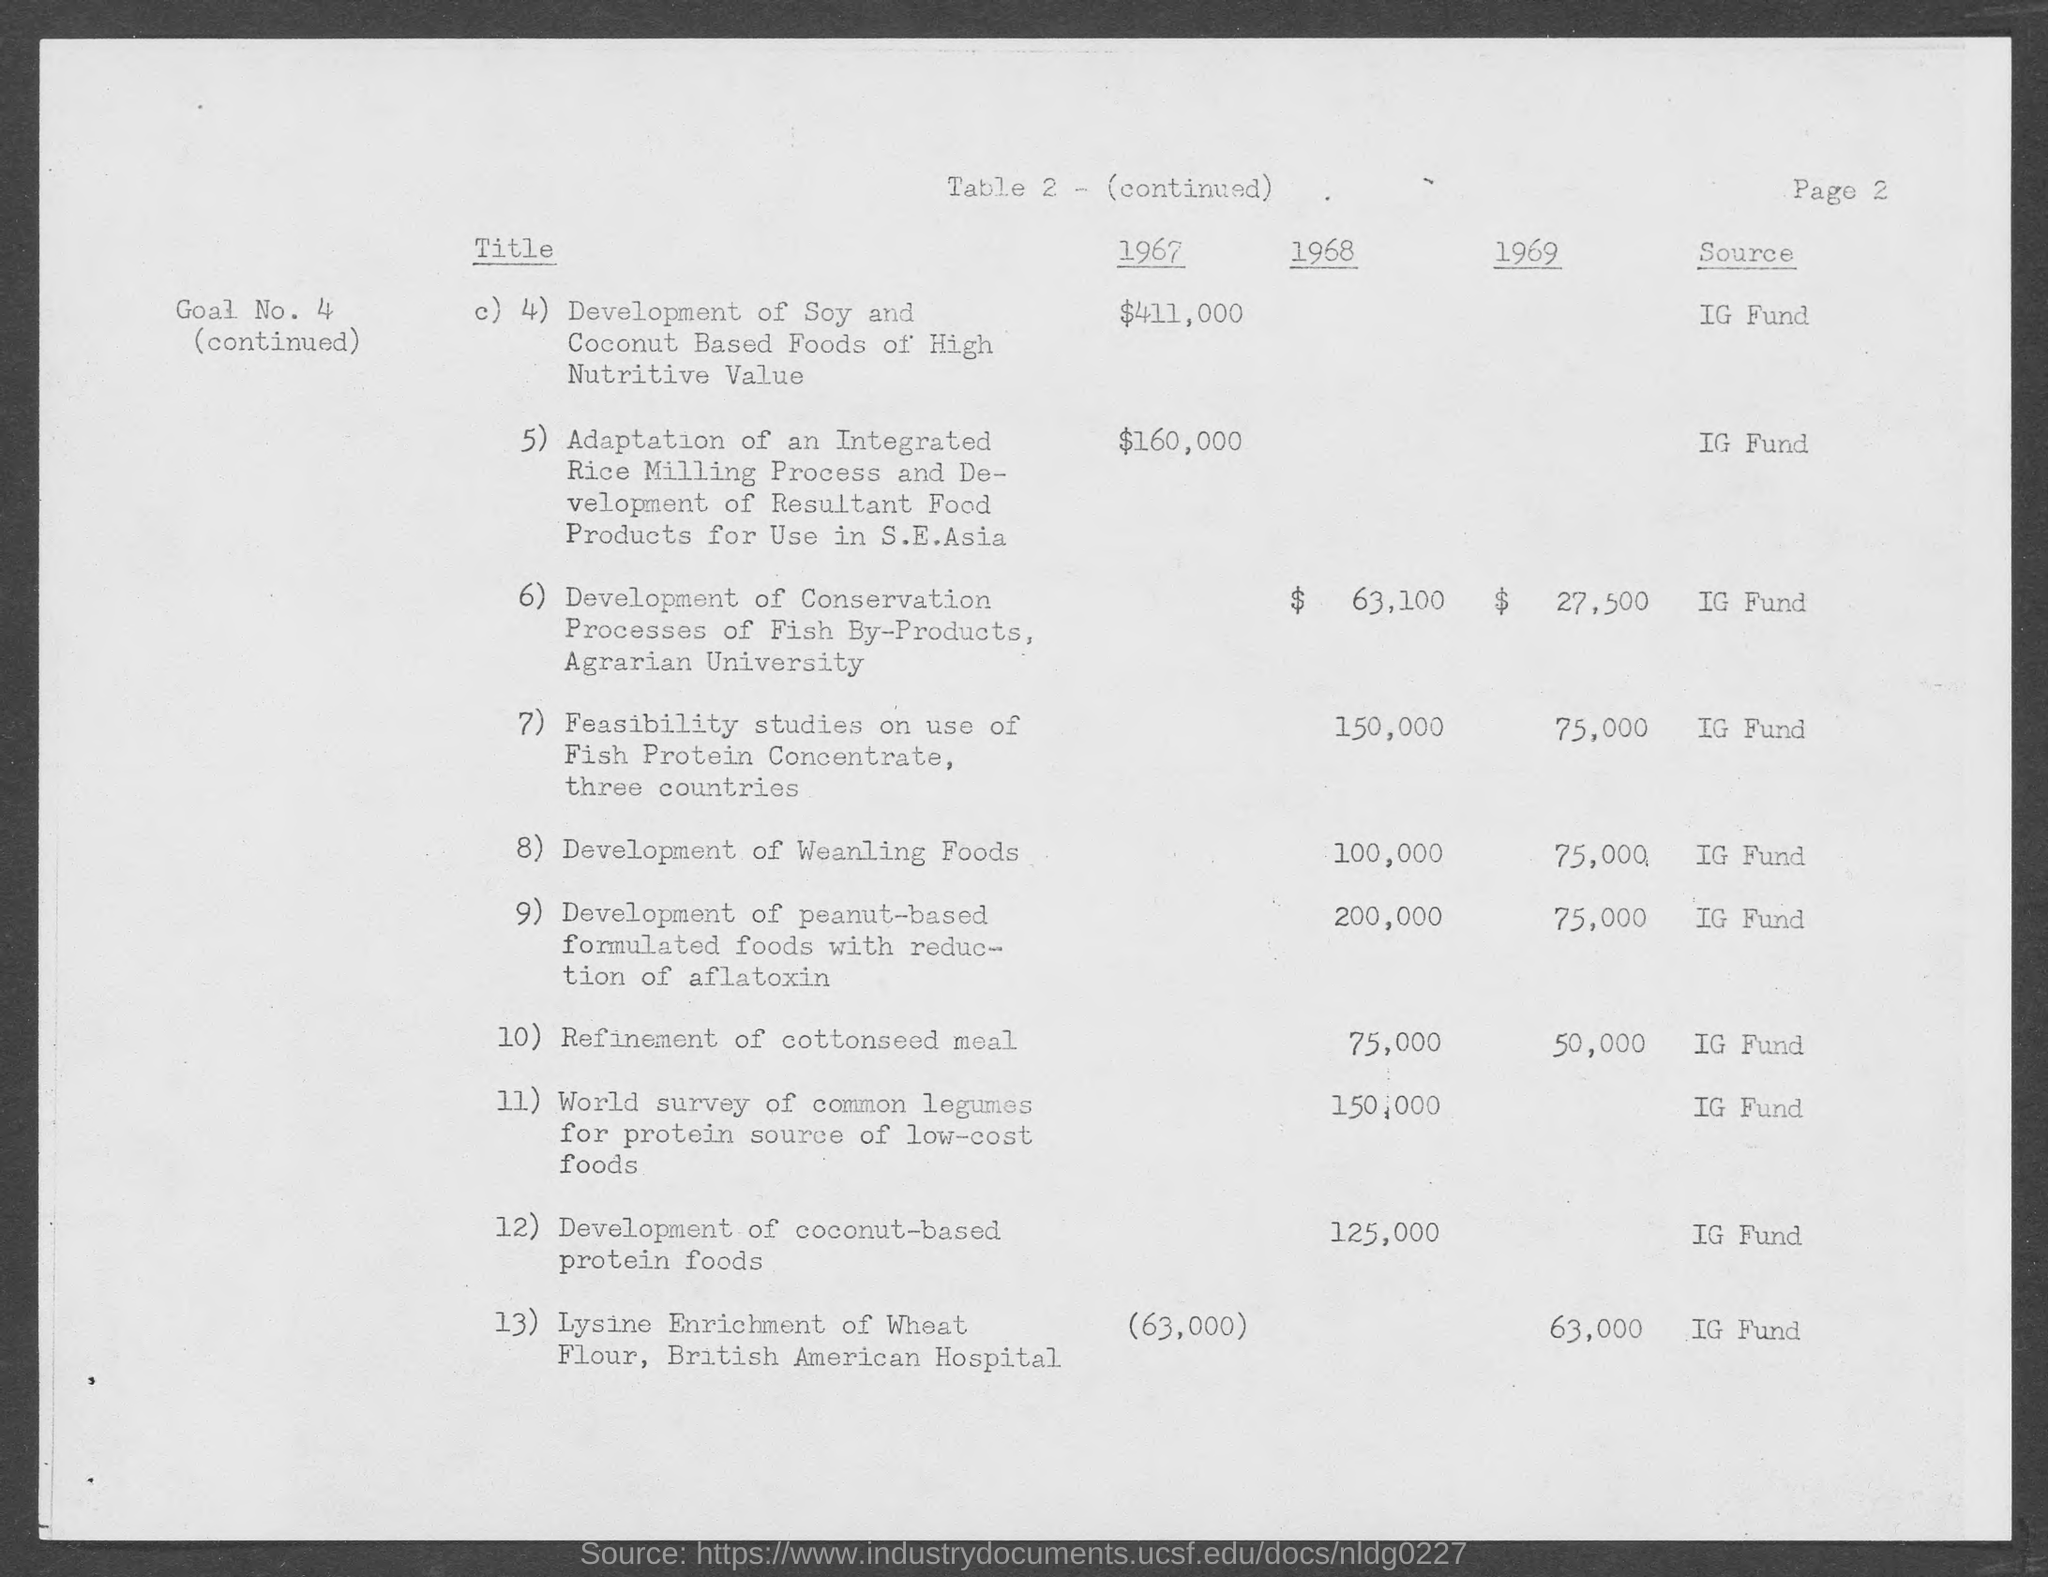Highlight a few significant elements in this photo. The feasibility studies for the use of fish protein concentrate have been conducted in three countries. I want to know the source of the funds for the amount mentioned, specifically an IG fund. 